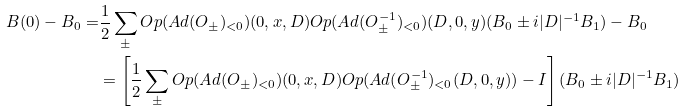<formula> <loc_0><loc_0><loc_500><loc_500>B ( 0 ) - B _ { 0 } = & \frac { 1 } { 2 } \sum _ { \pm } O p ( A d ( O _ { \pm } ) _ { < 0 } ) ( 0 , x , D ) O p ( A d ( O ^ { - 1 } _ { \pm } ) _ { < 0 } ) ( D , 0 , y ) ( B _ { 0 } \pm i | D | ^ { - 1 } B _ { 1 } ) - B _ { 0 } \\ & = \left [ \frac { 1 } { 2 } \sum _ { \pm } O p ( A d ( O _ { \pm } ) _ { < 0 } ) ( 0 , x , D ) O p ( A d ( O ^ { - 1 } _ { \pm } ) _ { < 0 } ( D , 0 , y ) ) - I \right ] ( B _ { 0 } \pm i | D | ^ { - 1 } B _ { 1 } )</formula> 